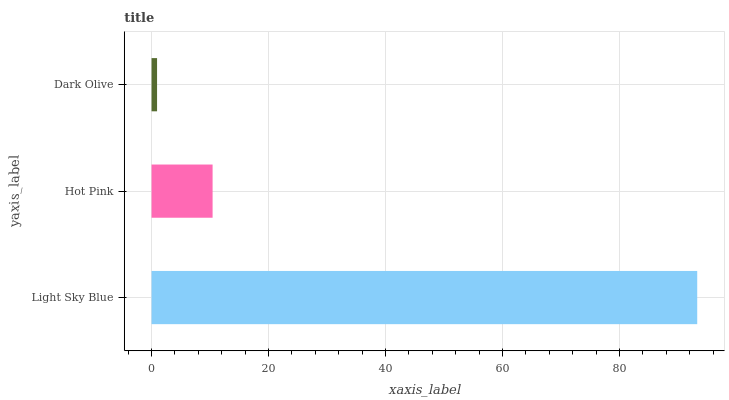Is Dark Olive the minimum?
Answer yes or no. Yes. Is Light Sky Blue the maximum?
Answer yes or no. Yes. Is Hot Pink the minimum?
Answer yes or no. No. Is Hot Pink the maximum?
Answer yes or no. No. Is Light Sky Blue greater than Hot Pink?
Answer yes or no. Yes. Is Hot Pink less than Light Sky Blue?
Answer yes or no. Yes. Is Hot Pink greater than Light Sky Blue?
Answer yes or no. No. Is Light Sky Blue less than Hot Pink?
Answer yes or no. No. Is Hot Pink the high median?
Answer yes or no. Yes. Is Hot Pink the low median?
Answer yes or no. Yes. Is Dark Olive the high median?
Answer yes or no. No. Is Light Sky Blue the low median?
Answer yes or no. No. 